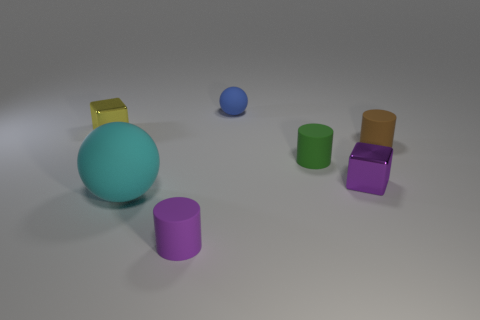Add 1 cylinders. How many objects exist? 8 Subtract all cubes. How many objects are left? 5 Subtract all tiny purple matte things. Subtract all tiny blue balls. How many objects are left? 5 Add 7 blue matte things. How many blue matte things are left? 8 Add 7 spheres. How many spheres exist? 9 Subtract 0 brown spheres. How many objects are left? 7 